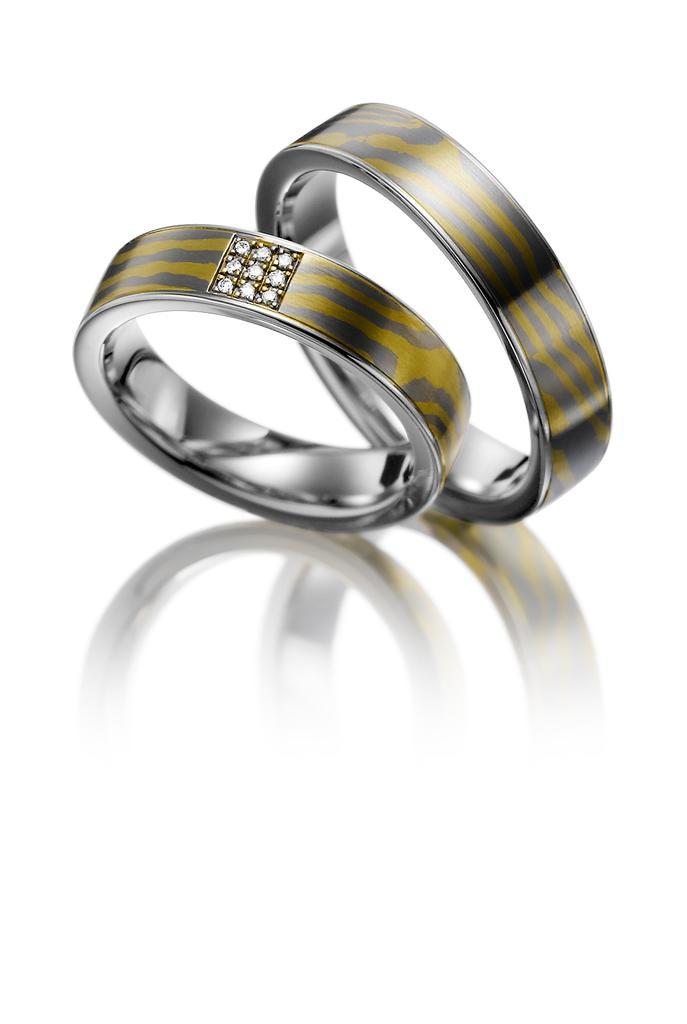Describe this image in one or two sentences. This image consists of rings. It looks like they are made up of platinum. In the middle, we can see the stones. 